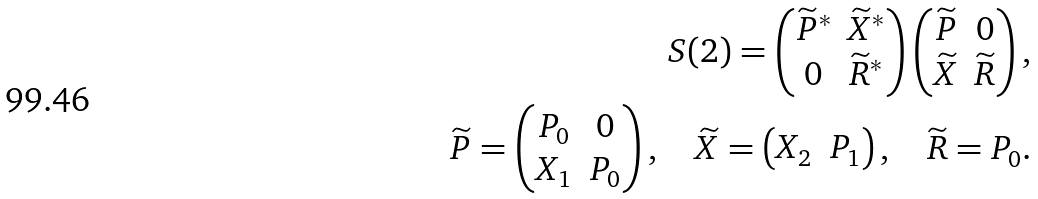<formula> <loc_0><loc_0><loc_500><loc_500>S ( 2 ) = \begin{pmatrix} { \widetilde { P } } ^ { * } & { \widetilde { X } } ^ { * } \\ 0 & { \widetilde { R } } ^ { * } \end{pmatrix} \begin{pmatrix} \widetilde { P } & 0 \\ \widetilde { X } & \widetilde { R } \end{pmatrix} , \\ \widetilde { P } = \begin{pmatrix} P _ { 0 } & 0 \\ X _ { 1 } & P _ { 0 } \end{pmatrix} , \quad \widetilde { X } = \begin{pmatrix} X _ { 2 } & P _ { 1 } \end{pmatrix} , \quad \widetilde { R } = P _ { 0 } .</formula> 